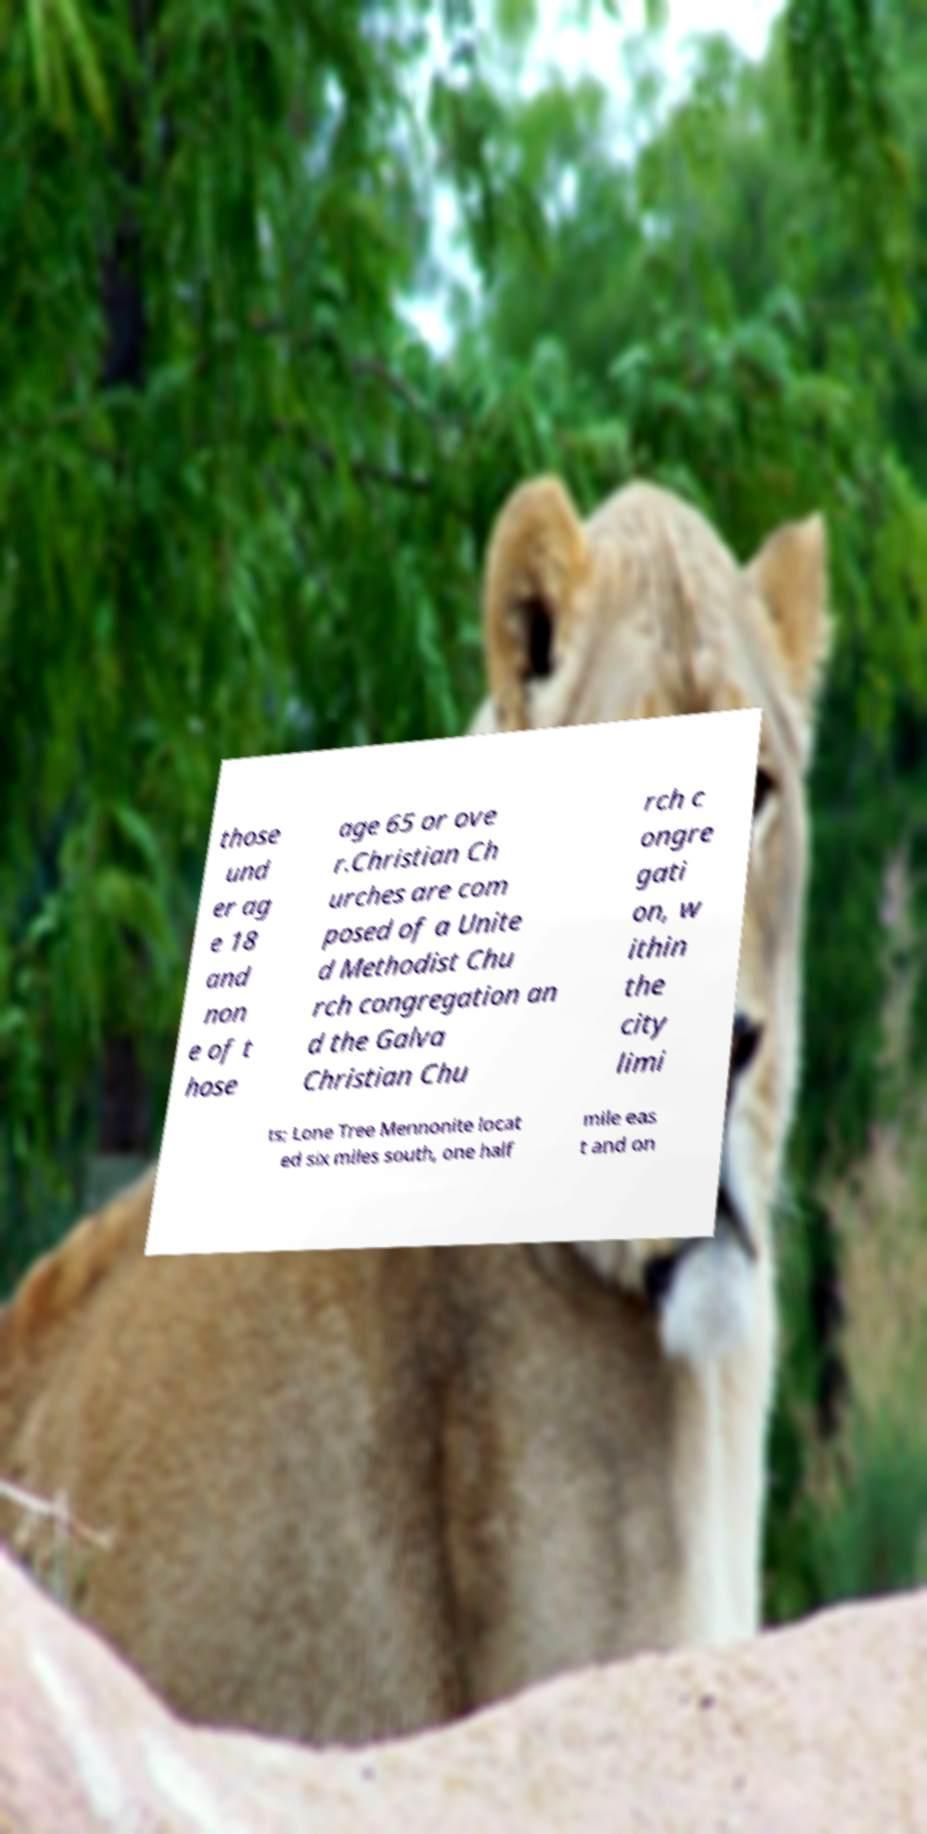I need the written content from this picture converted into text. Can you do that? those und er ag e 18 and non e of t hose age 65 or ove r.Christian Ch urches are com posed of a Unite d Methodist Chu rch congregation an d the Galva Christian Chu rch c ongre gati on, w ithin the city limi ts; Lone Tree Mennonite locat ed six miles south, one half mile eas t and on 